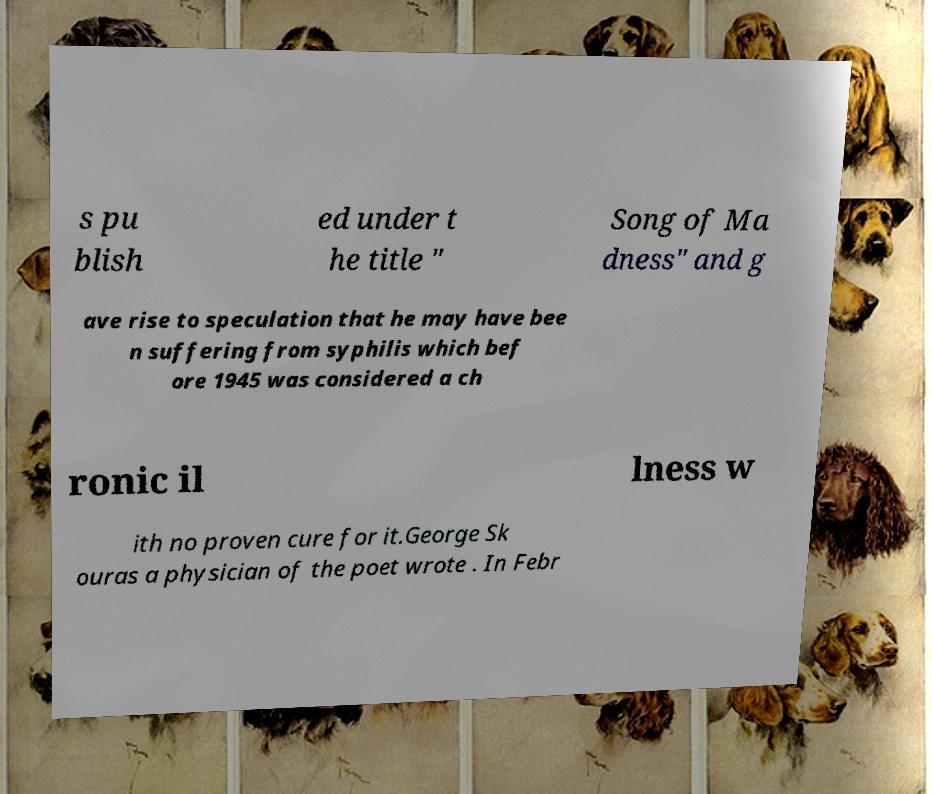There's text embedded in this image that I need extracted. Can you transcribe it verbatim? s pu blish ed under t he title " Song of Ma dness" and g ave rise to speculation that he may have bee n suffering from syphilis which bef ore 1945 was considered a ch ronic il lness w ith no proven cure for it.George Sk ouras a physician of the poet wrote . In Febr 